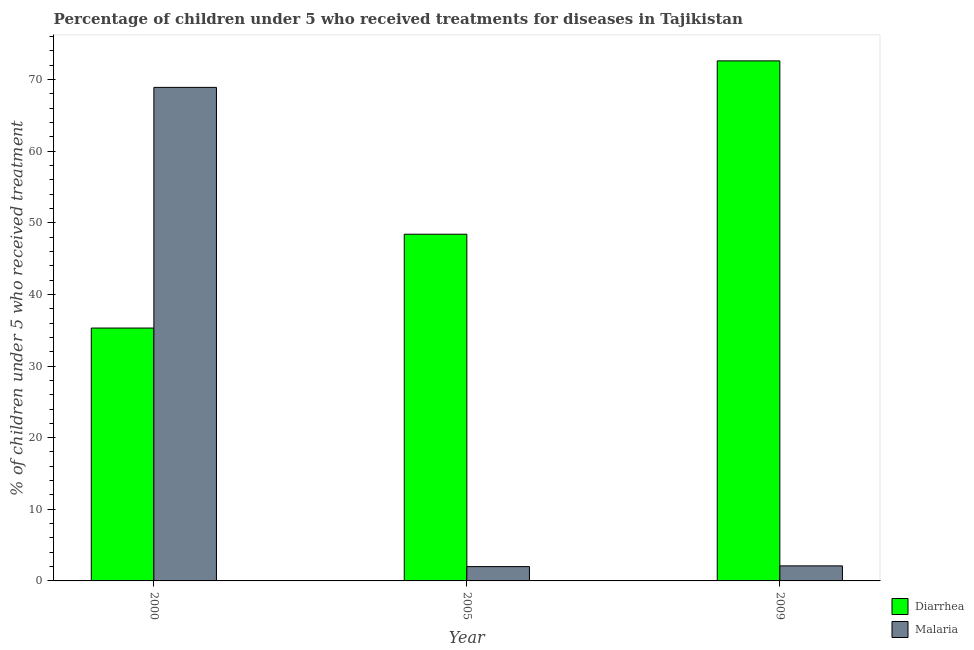How many groups of bars are there?
Offer a terse response. 3. Are the number of bars per tick equal to the number of legend labels?
Give a very brief answer. Yes. In how many cases, is the number of bars for a given year not equal to the number of legend labels?
Ensure brevity in your answer.  0. What is the percentage of children who received treatment for diarrhoea in 2005?
Offer a terse response. 48.4. Across all years, what is the maximum percentage of children who received treatment for malaria?
Keep it short and to the point. 68.9. Across all years, what is the minimum percentage of children who received treatment for malaria?
Provide a succinct answer. 2. In which year was the percentage of children who received treatment for malaria maximum?
Ensure brevity in your answer.  2000. What is the total percentage of children who received treatment for malaria in the graph?
Ensure brevity in your answer.  73. What is the difference between the percentage of children who received treatment for malaria in 2005 and that in 2009?
Ensure brevity in your answer.  -0.1. What is the difference between the percentage of children who received treatment for malaria in 2000 and the percentage of children who received treatment for diarrhoea in 2005?
Keep it short and to the point. 66.9. What is the average percentage of children who received treatment for malaria per year?
Offer a very short reply. 24.33. In how many years, is the percentage of children who received treatment for malaria greater than 50 %?
Provide a short and direct response. 1. What is the ratio of the percentage of children who received treatment for malaria in 2000 to that in 2005?
Your response must be concise. 34.45. What is the difference between the highest and the second highest percentage of children who received treatment for malaria?
Keep it short and to the point. 66.8. What is the difference between the highest and the lowest percentage of children who received treatment for malaria?
Offer a terse response. 66.9. In how many years, is the percentage of children who received treatment for diarrhoea greater than the average percentage of children who received treatment for diarrhoea taken over all years?
Make the answer very short. 1. Is the sum of the percentage of children who received treatment for diarrhoea in 2000 and 2005 greater than the maximum percentage of children who received treatment for malaria across all years?
Your answer should be compact. Yes. What does the 2nd bar from the left in 2005 represents?
Make the answer very short. Malaria. What does the 2nd bar from the right in 2000 represents?
Your answer should be very brief. Diarrhea. How many bars are there?
Keep it short and to the point. 6. Are all the bars in the graph horizontal?
Offer a very short reply. No. How many years are there in the graph?
Offer a terse response. 3. What is the difference between two consecutive major ticks on the Y-axis?
Give a very brief answer. 10. Does the graph contain any zero values?
Your answer should be compact. No. Does the graph contain grids?
Provide a succinct answer. No. What is the title of the graph?
Offer a very short reply. Percentage of children under 5 who received treatments for diseases in Tajikistan. What is the label or title of the X-axis?
Your answer should be compact. Year. What is the label or title of the Y-axis?
Offer a terse response. % of children under 5 who received treatment. What is the % of children under 5 who received treatment of Diarrhea in 2000?
Give a very brief answer. 35.3. What is the % of children under 5 who received treatment of Malaria in 2000?
Give a very brief answer. 68.9. What is the % of children under 5 who received treatment in Diarrhea in 2005?
Your response must be concise. 48.4. What is the % of children under 5 who received treatment in Diarrhea in 2009?
Provide a succinct answer. 72.6. Across all years, what is the maximum % of children under 5 who received treatment of Diarrhea?
Your answer should be very brief. 72.6. Across all years, what is the maximum % of children under 5 who received treatment in Malaria?
Offer a terse response. 68.9. Across all years, what is the minimum % of children under 5 who received treatment in Diarrhea?
Provide a succinct answer. 35.3. What is the total % of children under 5 who received treatment in Diarrhea in the graph?
Offer a terse response. 156.3. What is the difference between the % of children under 5 who received treatment in Diarrhea in 2000 and that in 2005?
Your answer should be very brief. -13.1. What is the difference between the % of children under 5 who received treatment of Malaria in 2000 and that in 2005?
Offer a terse response. 66.9. What is the difference between the % of children under 5 who received treatment in Diarrhea in 2000 and that in 2009?
Your answer should be very brief. -37.3. What is the difference between the % of children under 5 who received treatment in Malaria in 2000 and that in 2009?
Offer a very short reply. 66.8. What is the difference between the % of children under 5 who received treatment of Diarrhea in 2005 and that in 2009?
Your answer should be very brief. -24.2. What is the difference between the % of children under 5 who received treatment of Diarrhea in 2000 and the % of children under 5 who received treatment of Malaria in 2005?
Your response must be concise. 33.3. What is the difference between the % of children under 5 who received treatment in Diarrhea in 2000 and the % of children under 5 who received treatment in Malaria in 2009?
Provide a succinct answer. 33.2. What is the difference between the % of children under 5 who received treatment of Diarrhea in 2005 and the % of children under 5 who received treatment of Malaria in 2009?
Provide a succinct answer. 46.3. What is the average % of children under 5 who received treatment of Diarrhea per year?
Keep it short and to the point. 52.1. What is the average % of children under 5 who received treatment in Malaria per year?
Offer a very short reply. 24.33. In the year 2000, what is the difference between the % of children under 5 who received treatment of Diarrhea and % of children under 5 who received treatment of Malaria?
Offer a very short reply. -33.6. In the year 2005, what is the difference between the % of children under 5 who received treatment of Diarrhea and % of children under 5 who received treatment of Malaria?
Offer a very short reply. 46.4. In the year 2009, what is the difference between the % of children under 5 who received treatment of Diarrhea and % of children under 5 who received treatment of Malaria?
Your answer should be compact. 70.5. What is the ratio of the % of children under 5 who received treatment of Diarrhea in 2000 to that in 2005?
Provide a succinct answer. 0.73. What is the ratio of the % of children under 5 who received treatment in Malaria in 2000 to that in 2005?
Your answer should be very brief. 34.45. What is the ratio of the % of children under 5 who received treatment in Diarrhea in 2000 to that in 2009?
Your answer should be compact. 0.49. What is the ratio of the % of children under 5 who received treatment in Malaria in 2000 to that in 2009?
Give a very brief answer. 32.81. What is the ratio of the % of children under 5 who received treatment in Malaria in 2005 to that in 2009?
Provide a succinct answer. 0.95. What is the difference between the highest and the second highest % of children under 5 who received treatment in Diarrhea?
Make the answer very short. 24.2. What is the difference between the highest and the second highest % of children under 5 who received treatment of Malaria?
Keep it short and to the point. 66.8. What is the difference between the highest and the lowest % of children under 5 who received treatment of Diarrhea?
Provide a succinct answer. 37.3. What is the difference between the highest and the lowest % of children under 5 who received treatment in Malaria?
Provide a succinct answer. 66.9. 